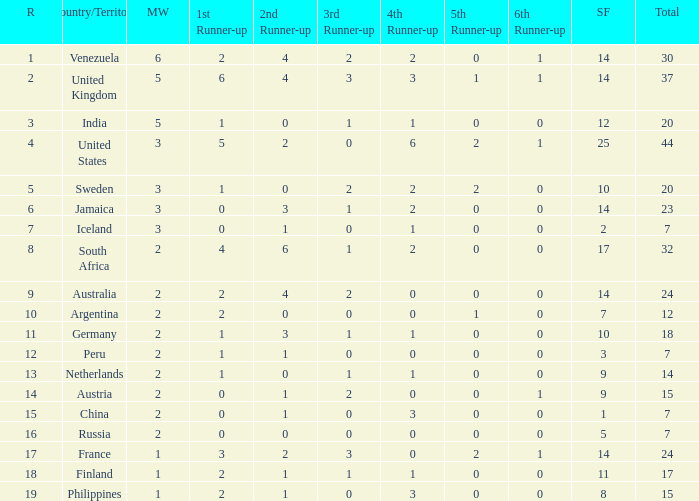What position does the united states hold in ranking? 1.0. 